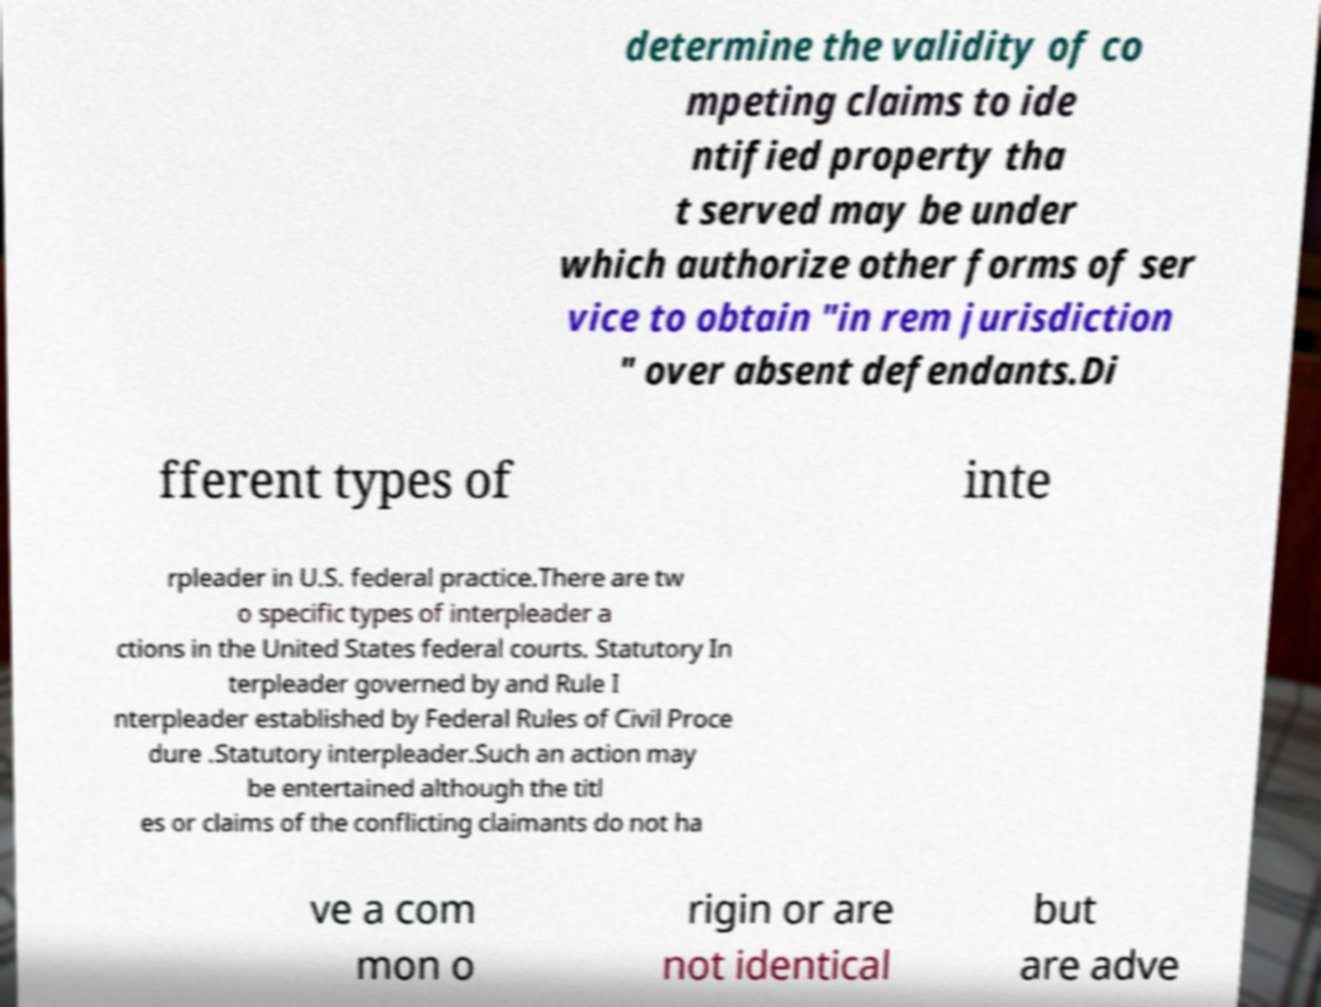Can you accurately transcribe the text from the provided image for me? determine the validity of co mpeting claims to ide ntified property tha t served may be under which authorize other forms of ser vice to obtain "in rem jurisdiction " over absent defendants.Di fferent types of inte rpleader in U.S. federal practice.There are tw o specific types of interpleader a ctions in the United States federal courts. Statutory In terpleader governed by and Rule I nterpleader established by Federal Rules of Civil Proce dure .Statutory interpleader.Such an action may be entertained although the titl es or claims of the conflicting claimants do not ha ve a com mon o rigin or are not identical but are adve 